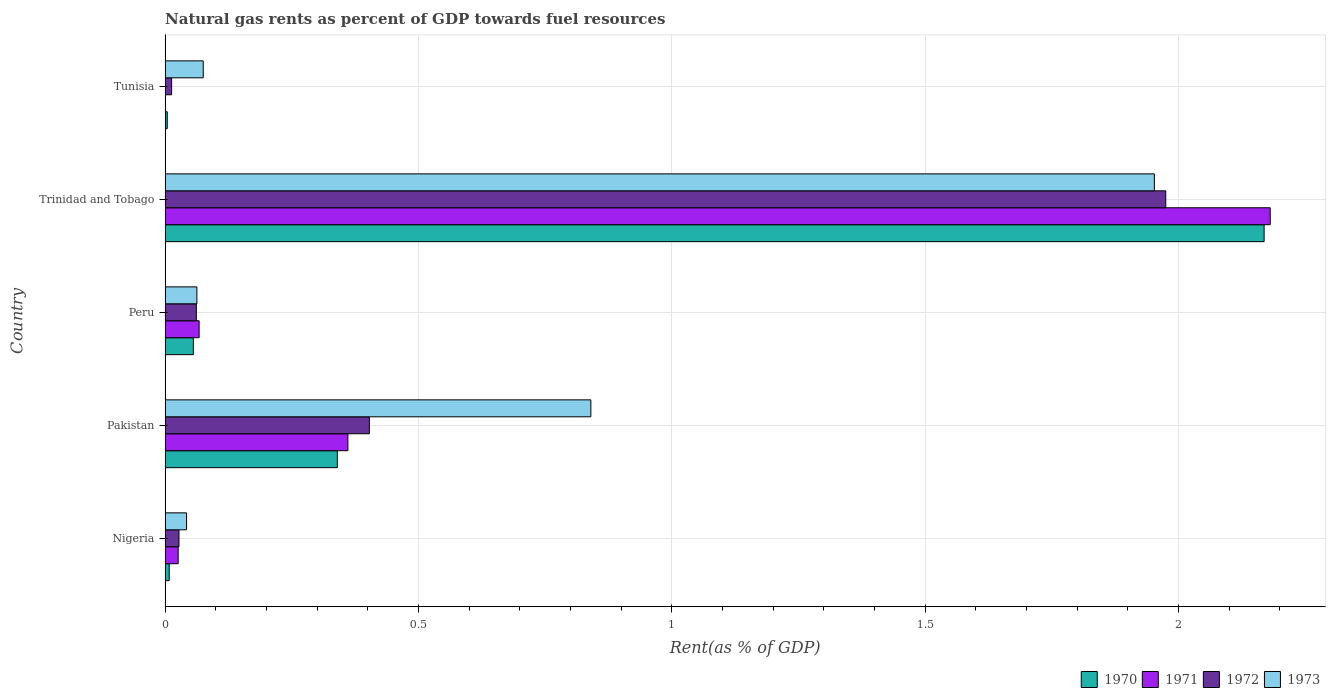How many groups of bars are there?
Your answer should be compact. 5. Are the number of bars per tick equal to the number of legend labels?
Offer a very short reply. Yes. What is the label of the 3rd group of bars from the top?
Offer a very short reply. Peru. What is the matural gas rent in 1972 in Pakistan?
Your response must be concise. 0.4. Across all countries, what is the maximum matural gas rent in 1972?
Offer a very short reply. 1.98. Across all countries, what is the minimum matural gas rent in 1970?
Give a very brief answer. 0. In which country was the matural gas rent in 1972 maximum?
Provide a succinct answer. Trinidad and Tobago. In which country was the matural gas rent in 1972 minimum?
Your answer should be compact. Tunisia. What is the total matural gas rent in 1973 in the graph?
Keep it short and to the point. 2.97. What is the difference between the matural gas rent in 1972 in Peru and that in Trinidad and Tobago?
Offer a very short reply. -1.91. What is the difference between the matural gas rent in 1971 in Tunisia and the matural gas rent in 1973 in Pakistan?
Keep it short and to the point. -0.84. What is the average matural gas rent in 1971 per country?
Ensure brevity in your answer.  0.53. What is the difference between the matural gas rent in 1972 and matural gas rent in 1970 in Peru?
Make the answer very short. 0.01. In how many countries, is the matural gas rent in 1973 greater than 0.1 %?
Your response must be concise. 2. What is the ratio of the matural gas rent in 1971 in Nigeria to that in Tunisia?
Your response must be concise. 34.77. Is the matural gas rent in 1972 in Pakistan less than that in Peru?
Provide a short and direct response. No. What is the difference between the highest and the second highest matural gas rent in 1972?
Provide a succinct answer. 1.57. What is the difference between the highest and the lowest matural gas rent in 1972?
Provide a short and direct response. 1.96. Is the sum of the matural gas rent in 1972 in Nigeria and Tunisia greater than the maximum matural gas rent in 1973 across all countries?
Ensure brevity in your answer.  No. What does the 3rd bar from the top in Tunisia represents?
Provide a succinct answer. 1971. Is it the case that in every country, the sum of the matural gas rent in 1973 and matural gas rent in 1971 is greater than the matural gas rent in 1970?
Give a very brief answer. Yes. Are all the bars in the graph horizontal?
Your response must be concise. Yes. How many countries are there in the graph?
Provide a short and direct response. 5. What is the difference between two consecutive major ticks on the X-axis?
Give a very brief answer. 0.5. Are the values on the major ticks of X-axis written in scientific E-notation?
Provide a succinct answer. No. Does the graph contain grids?
Keep it short and to the point. Yes. How many legend labels are there?
Ensure brevity in your answer.  4. How are the legend labels stacked?
Your response must be concise. Horizontal. What is the title of the graph?
Your answer should be compact. Natural gas rents as percent of GDP towards fuel resources. Does "1988" appear as one of the legend labels in the graph?
Keep it short and to the point. No. What is the label or title of the X-axis?
Your answer should be compact. Rent(as % of GDP). What is the label or title of the Y-axis?
Your response must be concise. Country. What is the Rent(as % of GDP) of 1970 in Nigeria?
Provide a short and direct response. 0.01. What is the Rent(as % of GDP) of 1971 in Nigeria?
Make the answer very short. 0.03. What is the Rent(as % of GDP) in 1972 in Nigeria?
Offer a very short reply. 0.03. What is the Rent(as % of GDP) of 1973 in Nigeria?
Provide a succinct answer. 0.04. What is the Rent(as % of GDP) of 1970 in Pakistan?
Give a very brief answer. 0.34. What is the Rent(as % of GDP) in 1971 in Pakistan?
Give a very brief answer. 0.36. What is the Rent(as % of GDP) in 1972 in Pakistan?
Offer a terse response. 0.4. What is the Rent(as % of GDP) in 1973 in Pakistan?
Keep it short and to the point. 0.84. What is the Rent(as % of GDP) in 1970 in Peru?
Ensure brevity in your answer.  0.06. What is the Rent(as % of GDP) of 1971 in Peru?
Provide a succinct answer. 0.07. What is the Rent(as % of GDP) of 1972 in Peru?
Your answer should be very brief. 0.06. What is the Rent(as % of GDP) of 1973 in Peru?
Offer a very short reply. 0.06. What is the Rent(as % of GDP) of 1970 in Trinidad and Tobago?
Keep it short and to the point. 2.17. What is the Rent(as % of GDP) of 1971 in Trinidad and Tobago?
Provide a succinct answer. 2.18. What is the Rent(as % of GDP) of 1972 in Trinidad and Tobago?
Offer a terse response. 1.98. What is the Rent(as % of GDP) in 1973 in Trinidad and Tobago?
Ensure brevity in your answer.  1.95. What is the Rent(as % of GDP) in 1970 in Tunisia?
Give a very brief answer. 0. What is the Rent(as % of GDP) of 1971 in Tunisia?
Give a very brief answer. 0. What is the Rent(as % of GDP) in 1972 in Tunisia?
Give a very brief answer. 0.01. What is the Rent(as % of GDP) of 1973 in Tunisia?
Offer a very short reply. 0.08. Across all countries, what is the maximum Rent(as % of GDP) of 1970?
Provide a short and direct response. 2.17. Across all countries, what is the maximum Rent(as % of GDP) of 1971?
Offer a very short reply. 2.18. Across all countries, what is the maximum Rent(as % of GDP) of 1972?
Your answer should be very brief. 1.98. Across all countries, what is the maximum Rent(as % of GDP) of 1973?
Provide a succinct answer. 1.95. Across all countries, what is the minimum Rent(as % of GDP) in 1970?
Give a very brief answer. 0. Across all countries, what is the minimum Rent(as % of GDP) in 1971?
Your answer should be very brief. 0. Across all countries, what is the minimum Rent(as % of GDP) in 1972?
Provide a short and direct response. 0.01. Across all countries, what is the minimum Rent(as % of GDP) of 1973?
Offer a very short reply. 0.04. What is the total Rent(as % of GDP) of 1970 in the graph?
Offer a terse response. 2.58. What is the total Rent(as % of GDP) of 1971 in the graph?
Your response must be concise. 2.64. What is the total Rent(as % of GDP) in 1972 in the graph?
Keep it short and to the point. 2.48. What is the total Rent(as % of GDP) in 1973 in the graph?
Keep it short and to the point. 2.97. What is the difference between the Rent(as % of GDP) in 1970 in Nigeria and that in Pakistan?
Provide a short and direct response. -0.33. What is the difference between the Rent(as % of GDP) of 1971 in Nigeria and that in Pakistan?
Your answer should be very brief. -0.34. What is the difference between the Rent(as % of GDP) in 1972 in Nigeria and that in Pakistan?
Give a very brief answer. -0.38. What is the difference between the Rent(as % of GDP) in 1973 in Nigeria and that in Pakistan?
Keep it short and to the point. -0.8. What is the difference between the Rent(as % of GDP) in 1970 in Nigeria and that in Peru?
Give a very brief answer. -0.05. What is the difference between the Rent(as % of GDP) of 1971 in Nigeria and that in Peru?
Give a very brief answer. -0.04. What is the difference between the Rent(as % of GDP) in 1972 in Nigeria and that in Peru?
Provide a short and direct response. -0.03. What is the difference between the Rent(as % of GDP) of 1973 in Nigeria and that in Peru?
Offer a very short reply. -0.02. What is the difference between the Rent(as % of GDP) of 1970 in Nigeria and that in Trinidad and Tobago?
Offer a very short reply. -2.16. What is the difference between the Rent(as % of GDP) in 1971 in Nigeria and that in Trinidad and Tobago?
Ensure brevity in your answer.  -2.16. What is the difference between the Rent(as % of GDP) of 1972 in Nigeria and that in Trinidad and Tobago?
Provide a succinct answer. -1.95. What is the difference between the Rent(as % of GDP) of 1973 in Nigeria and that in Trinidad and Tobago?
Your response must be concise. -1.91. What is the difference between the Rent(as % of GDP) in 1970 in Nigeria and that in Tunisia?
Offer a terse response. 0. What is the difference between the Rent(as % of GDP) of 1971 in Nigeria and that in Tunisia?
Make the answer very short. 0.03. What is the difference between the Rent(as % of GDP) of 1972 in Nigeria and that in Tunisia?
Make the answer very short. 0.01. What is the difference between the Rent(as % of GDP) of 1973 in Nigeria and that in Tunisia?
Give a very brief answer. -0.03. What is the difference between the Rent(as % of GDP) in 1970 in Pakistan and that in Peru?
Make the answer very short. 0.28. What is the difference between the Rent(as % of GDP) of 1971 in Pakistan and that in Peru?
Ensure brevity in your answer.  0.29. What is the difference between the Rent(as % of GDP) of 1972 in Pakistan and that in Peru?
Ensure brevity in your answer.  0.34. What is the difference between the Rent(as % of GDP) of 1973 in Pakistan and that in Peru?
Keep it short and to the point. 0.78. What is the difference between the Rent(as % of GDP) in 1970 in Pakistan and that in Trinidad and Tobago?
Ensure brevity in your answer.  -1.83. What is the difference between the Rent(as % of GDP) in 1971 in Pakistan and that in Trinidad and Tobago?
Offer a terse response. -1.82. What is the difference between the Rent(as % of GDP) in 1972 in Pakistan and that in Trinidad and Tobago?
Your answer should be very brief. -1.57. What is the difference between the Rent(as % of GDP) in 1973 in Pakistan and that in Trinidad and Tobago?
Make the answer very short. -1.11. What is the difference between the Rent(as % of GDP) in 1970 in Pakistan and that in Tunisia?
Offer a terse response. 0.34. What is the difference between the Rent(as % of GDP) of 1971 in Pakistan and that in Tunisia?
Provide a short and direct response. 0.36. What is the difference between the Rent(as % of GDP) of 1972 in Pakistan and that in Tunisia?
Give a very brief answer. 0.39. What is the difference between the Rent(as % of GDP) of 1973 in Pakistan and that in Tunisia?
Offer a very short reply. 0.77. What is the difference between the Rent(as % of GDP) in 1970 in Peru and that in Trinidad and Tobago?
Ensure brevity in your answer.  -2.11. What is the difference between the Rent(as % of GDP) in 1971 in Peru and that in Trinidad and Tobago?
Provide a succinct answer. -2.11. What is the difference between the Rent(as % of GDP) in 1972 in Peru and that in Trinidad and Tobago?
Make the answer very short. -1.91. What is the difference between the Rent(as % of GDP) of 1973 in Peru and that in Trinidad and Tobago?
Make the answer very short. -1.89. What is the difference between the Rent(as % of GDP) of 1970 in Peru and that in Tunisia?
Your answer should be compact. 0.05. What is the difference between the Rent(as % of GDP) of 1971 in Peru and that in Tunisia?
Make the answer very short. 0.07. What is the difference between the Rent(as % of GDP) of 1972 in Peru and that in Tunisia?
Provide a short and direct response. 0.05. What is the difference between the Rent(as % of GDP) of 1973 in Peru and that in Tunisia?
Make the answer very short. -0.01. What is the difference between the Rent(as % of GDP) in 1970 in Trinidad and Tobago and that in Tunisia?
Make the answer very short. 2.17. What is the difference between the Rent(as % of GDP) of 1971 in Trinidad and Tobago and that in Tunisia?
Offer a very short reply. 2.18. What is the difference between the Rent(as % of GDP) of 1972 in Trinidad and Tobago and that in Tunisia?
Your answer should be compact. 1.96. What is the difference between the Rent(as % of GDP) in 1973 in Trinidad and Tobago and that in Tunisia?
Your answer should be very brief. 1.88. What is the difference between the Rent(as % of GDP) in 1970 in Nigeria and the Rent(as % of GDP) in 1971 in Pakistan?
Offer a very short reply. -0.35. What is the difference between the Rent(as % of GDP) of 1970 in Nigeria and the Rent(as % of GDP) of 1972 in Pakistan?
Make the answer very short. -0.4. What is the difference between the Rent(as % of GDP) in 1970 in Nigeria and the Rent(as % of GDP) in 1973 in Pakistan?
Your response must be concise. -0.83. What is the difference between the Rent(as % of GDP) in 1971 in Nigeria and the Rent(as % of GDP) in 1972 in Pakistan?
Your answer should be compact. -0.38. What is the difference between the Rent(as % of GDP) of 1971 in Nigeria and the Rent(as % of GDP) of 1973 in Pakistan?
Your answer should be compact. -0.81. What is the difference between the Rent(as % of GDP) of 1972 in Nigeria and the Rent(as % of GDP) of 1973 in Pakistan?
Offer a terse response. -0.81. What is the difference between the Rent(as % of GDP) in 1970 in Nigeria and the Rent(as % of GDP) in 1971 in Peru?
Your answer should be compact. -0.06. What is the difference between the Rent(as % of GDP) of 1970 in Nigeria and the Rent(as % of GDP) of 1972 in Peru?
Your answer should be very brief. -0.05. What is the difference between the Rent(as % of GDP) of 1970 in Nigeria and the Rent(as % of GDP) of 1973 in Peru?
Provide a short and direct response. -0.05. What is the difference between the Rent(as % of GDP) in 1971 in Nigeria and the Rent(as % of GDP) in 1972 in Peru?
Keep it short and to the point. -0.04. What is the difference between the Rent(as % of GDP) of 1971 in Nigeria and the Rent(as % of GDP) of 1973 in Peru?
Offer a very short reply. -0.04. What is the difference between the Rent(as % of GDP) of 1972 in Nigeria and the Rent(as % of GDP) of 1973 in Peru?
Ensure brevity in your answer.  -0.04. What is the difference between the Rent(as % of GDP) of 1970 in Nigeria and the Rent(as % of GDP) of 1971 in Trinidad and Tobago?
Offer a terse response. -2.17. What is the difference between the Rent(as % of GDP) in 1970 in Nigeria and the Rent(as % of GDP) in 1972 in Trinidad and Tobago?
Ensure brevity in your answer.  -1.97. What is the difference between the Rent(as % of GDP) of 1970 in Nigeria and the Rent(as % of GDP) of 1973 in Trinidad and Tobago?
Provide a short and direct response. -1.94. What is the difference between the Rent(as % of GDP) in 1971 in Nigeria and the Rent(as % of GDP) in 1972 in Trinidad and Tobago?
Your answer should be compact. -1.95. What is the difference between the Rent(as % of GDP) in 1971 in Nigeria and the Rent(as % of GDP) in 1973 in Trinidad and Tobago?
Provide a short and direct response. -1.93. What is the difference between the Rent(as % of GDP) in 1972 in Nigeria and the Rent(as % of GDP) in 1973 in Trinidad and Tobago?
Offer a very short reply. -1.93. What is the difference between the Rent(as % of GDP) in 1970 in Nigeria and the Rent(as % of GDP) in 1971 in Tunisia?
Your response must be concise. 0.01. What is the difference between the Rent(as % of GDP) of 1970 in Nigeria and the Rent(as % of GDP) of 1972 in Tunisia?
Give a very brief answer. -0. What is the difference between the Rent(as % of GDP) of 1970 in Nigeria and the Rent(as % of GDP) of 1973 in Tunisia?
Make the answer very short. -0.07. What is the difference between the Rent(as % of GDP) in 1971 in Nigeria and the Rent(as % of GDP) in 1972 in Tunisia?
Keep it short and to the point. 0.01. What is the difference between the Rent(as % of GDP) in 1971 in Nigeria and the Rent(as % of GDP) in 1973 in Tunisia?
Your answer should be very brief. -0.05. What is the difference between the Rent(as % of GDP) of 1972 in Nigeria and the Rent(as % of GDP) of 1973 in Tunisia?
Provide a succinct answer. -0.05. What is the difference between the Rent(as % of GDP) of 1970 in Pakistan and the Rent(as % of GDP) of 1971 in Peru?
Ensure brevity in your answer.  0.27. What is the difference between the Rent(as % of GDP) of 1970 in Pakistan and the Rent(as % of GDP) of 1972 in Peru?
Give a very brief answer. 0.28. What is the difference between the Rent(as % of GDP) of 1970 in Pakistan and the Rent(as % of GDP) of 1973 in Peru?
Ensure brevity in your answer.  0.28. What is the difference between the Rent(as % of GDP) of 1971 in Pakistan and the Rent(as % of GDP) of 1972 in Peru?
Offer a terse response. 0.3. What is the difference between the Rent(as % of GDP) of 1971 in Pakistan and the Rent(as % of GDP) of 1973 in Peru?
Your response must be concise. 0.3. What is the difference between the Rent(as % of GDP) of 1972 in Pakistan and the Rent(as % of GDP) of 1973 in Peru?
Offer a very short reply. 0.34. What is the difference between the Rent(as % of GDP) in 1970 in Pakistan and the Rent(as % of GDP) in 1971 in Trinidad and Tobago?
Give a very brief answer. -1.84. What is the difference between the Rent(as % of GDP) in 1970 in Pakistan and the Rent(as % of GDP) in 1972 in Trinidad and Tobago?
Make the answer very short. -1.64. What is the difference between the Rent(as % of GDP) in 1970 in Pakistan and the Rent(as % of GDP) in 1973 in Trinidad and Tobago?
Provide a succinct answer. -1.61. What is the difference between the Rent(as % of GDP) of 1971 in Pakistan and the Rent(as % of GDP) of 1972 in Trinidad and Tobago?
Keep it short and to the point. -1.61. What is the difference between the Rent(as % of GDP) in 1971 in Pakistan and the Rent(as % of GDP) in 1973 in Trinidad and Tobago?
Your answer should be compact. -1.59. What is the difference between the Rent(as % of GDP) in 1972 in Pakistan and the Rent(as % of GDP) in 1973 in Trinidad and Tobago?
Ensure brevity in your answer.  -1.55. What is the difference between the Rent(as % of GDP) of 1970 in Pakistan and the Rent(as % of GDP) of 1971 in Tunisia?
Offer a very short reply. 0.34. What is the difference between the Rent(as % of GDP) of 1970 in Pakistan and the Rent(as % of GDP) of 1972 in Tunisia?
Offer a very short reply. 0.33. What is the difference between the Rent(as % of GDP) in 1970 in Pakistan and the Rent(as % of GDP) in 1973 in Tunisia?
Offer a very short reply. 0.26. What is the difference between the Rent(as % of GDP) of 1971 in Pakistan and the Rent(as % of GDP) of 1972 in Tunisia?
Ensure brevity in your answer.  0.35. What is the difference between the Rent(as % of GDP) of 1971 in Pakistan and the Rent(as % of GDP) of 1973 in Tunisia?
Your response must be concise. 0.29. What is the difference between the Rent(as % of GDP) in 1972 in Pakistan and the Rent(as % of GDP) in 1973 in Tunisia?
Your response must be concise. 0.33. What is the difference between the Rent(as % of GDP) in 1970 in Peru and the Rent(as % of GDP) in 1971 in Trinidad and Tobago?
Give a very brief answer. -2.13. What is the difference between the Rent(as % of GDP) of 1970 in Peru and the Rent(as % of GDP) of 1972 in Trinidad and Tobago?
Make the answer very short. -1.92. What is the difference between the Rent(as % of GDP) of 1970 in Peru and the Rent(as % of GDP) of 1973 in Trinidad and Tobago?
Make the answer very short. -1.9. What is the difference between the Rent(as % of GDP) in 1971 in Peru and the Rent(as % of GDP) in 1972 in Trinidad and Tobago?
Ensure brevity in your answer.  -1.91. What is the difference between the Rent(as % of GDP) of 1971 in Peru and the Rent(as % of GDP) of 1973 in Trinidad and Tobago?
Offer a terse response. -1.89. What is the difference between the Rent(as % of GDP) in 1972 in Peru and the Rent(as % of GDP) in 1973 in Trinidad and Tobago?
Your answer should be very brief. -1.89. What is the difference between the Rent(as % of GDP) of 1970 in Peru and the Rent(as % of GDP) of 1971 in Tunisia?
Make the answer very short. 0.06. What is the difference between the Rent(as % of GDP) of 1970 in Peru and the Rent(as % of GDP) of 1972 in Tunisia?
Provide a succinct answer. 0.04. What is the difference between the Rent(as % of GDP) in 1970 in Peru and the Rent(as % of GDP) in 1973 in Tunisia?
Provide a succinct answer. -0.02. What is the difference between the Rent(as % of GDP) of 1971 in Peru and the Rent(as % of GDP) of 1972 in Tunisia?
Offer a very short reply. 0.05. What is the difference between the Rent(as % of GDP) in 1971 in Peru and the Rent(as % of GDP) in 1973 in Tunisia?
Your answer should be compact. -0.01. What is the difference between the Rent(as % of GDP) of 1972 in Peru and the Rent(as % of GDP) of 1973 in Tunisia?
Offer a terse response. -0.01. What is the difference between the Rent(as % of GDP) in 1970 in Trinidad and Tobago and the Rent(as % of GDP) in 1971 in Tunisia?
Make the answer very short. 2.17. What is the difference between the Rent(as % of GDP) in 1970 in Trinidad and Tobago and the Rent(as % of GDP) in 1972 in Tunisia?
Make the answer very short. 2.16. What is the difference between the Rent(as % of GDP) of 1970 in Trinidad and Tobago and the Rent(as % of GDP) of 1973 in Tunisia?
Offer a terse response. 2.09. What is the difference between the Rent(as % of GDP) in 1971 in Trinidad and Tobago and the Rent(as % of GDP) in 1972 in Tunisia?
Offer a terse response. 2.17. What is the difference between the Rent(as % of GDP) of 1971 in Trinidad and Tobago and the Rent(as % of GDP) of 1973 in Tunisia?
Provide a succinct answer. 2.11. What is the difference between the Rent(as % of GDP) of 1972 in Trinidad and Tobago and the Rent(as % of GDP) of 1973 in Tunisia?
Ensure brevity in your answer.  1.9. What is the average Rent(as % of GDP) of 1970 per country?
Make the answer very short. 0.52. What is the average Rent(as % of GDP) in 1971 per country?
Offer a very short reply. 0.53. What is the average Rent(as % of GDP) in 1972 per country?
Offer a terse response. 0.5. What is the average Rent(as % of GDP) in 1973 per country?
Your response must be concise. 0.59. What is the difference between the Rent(as % of GDP) of 1970 and Rent(as % of GDP) of 1971 in Nigeria?
Offer a very short reply. -0.02. What is the difference between the Rent(as % of GDP) in 1970 and Rent(as % of GDP) in 1972 in Nigeria?
Make the answer very short. -0.02. What is the difference between the Rent(as % of GDP) in 1970 and Rent(as % of GDP) in 1973 in Nigeria?
Ensure brevity in your answer.  -0.03. What is the difference between the Rent(as % of GDP) of 1971 and Rent(as % of GDP) of 1972 in Nigeria?
Your response must be concise. -0. What is the difference between the Rent(as % of GDP) in 1971 and Rent(as % of GDP) in 1973 in Nigeria?
Your answer should be very brief. -0.02. What is the difference between the Rent(as % of GDP) of 1972 and Rent(as % of GDP) of 1973 in Nigeria?
Make the answer very short. -0.01. What is the difference between the Rent(as % of GDP) of 1970 and Rent(as % of GDP) of 1971 in Pakistan?
Your answer should be compact. -0.02. What is the difference between the Rent(as % of GDP) in 1970 and Rent(as % of GDP) in 1972 in Pakistan?
Your answer should be very brief. -0.06. What is the difference between the Rent(as % of GDP) of 1970 and Rent(as % of GDP) of 1973 in Pakistan?
Your answer should be compact. -0.5. What is the difference between the Rent(as % of GDP) in 1971 and Rent(as % of GDP) in 1972 in Pakistan?
Offer a very short reply. -0.04. What is the difference between the Rent(as % of GDP) of 1971 and Rent(as % of GDP) of 1973 in Pakistan?
Ensure brevity in your answer.  -0.48. What is the difference between the Rent(as % of GDP) of 1972 and Rent(as % of GDP) of 1973 in Pakistan?
Ensure brevity in your answer.  -0.44. What is the difference between the Rent(as % of GDP) of 1970 and Rent(as % of GDP) of 1971 in Peru?
Provide a short and direct response. -0.01. What is the difference between the Rent(as % of GDP) in 1970 and Rent(as % of GDP) in 1972 in Peru?
Your answer should be very brief. -0.01. What is the difference between the Rent(as % of GDP) in 1970 and Rent(as % of GDP) in 1973 in Peru?
Ensure brevity in your answer.  -0.01. What is the difference between the Rent(as % of GDP) in 1971 and Rent(as % of GDP) in 1972 in Peru?
Provide a short and direct response. 0.01. What is the difference between the Rent(as % of GDP) of 1971 and Rent(as % of GDP) of 1973 in Peru?
Your answer should be very brief. 0. What is the difference between the Rent(as % of GDP) in 1972 and Rent(as % of GDP) in 1973 in Peru?
Your answer should be compact. -0. What is the difference between the Rent(as % of GDP) of 1970 and Rent(as % of GDP) of 1971 in Trinidad and Tobago?
Your answer should be compact. -0.01. What is the difference between the Rent(as % of GDP) of 1970 and Rent(as % of GDP) of 1972 in Trinidad and Tobago?
Ensure brevity in your answer.  0.19. What is the difference between the Rent(as % of GDP) of 1970 and Rent(as % of GDP) of 1973 in Trinidad and Tobago?
Keep it short and to the point. 0.22. What is the difference between the Rent(as % of GDP) in 1971 and Rent(as % of GDP) in 1972 in Trinidad and Tobago?
Provide a short and direct response. 0.21. What is the difference between the Rent(as % of GDP) in 1971 and Rent(as % of GDP) in 1973 in Trinidad and Tobago?
Provide a short and direct response. 0.23. What is the difference between the Rent(as % of GDP) in 1972 and Rent(as % of GDP) in 1973 in Trinidad and Tobago?
Provide a succinct answer. 0.02. What is the difference between the Rent(as % of GDP) in 1970 and Rent(as % of GDP) in 1971 in Tunisia?
Your answer should be very brief. 0. What is the difference between the Rent(as % of GDP) in 1970 and Rent(as % of GDP) in 1972 in Tunisia?
Your answer should be very brief. -0.01. What is the difference between the Rent(as % of GDP) of 1970 and Rent(as % of GDP) of 1973 in Tunisia?
Your answer should be very brief. -0.07. What is the difference between the Rent(as % of GDP) of 1971 and Rent(as % of GDP) of 1972 in Tunisia?
Your answer should be very brief. -0.01. What is the difference between the Rent(as % of GDP) of 1971 and Rent(as % of GDP) of 1973 in Tunisia?
Offer a very short reply. -0.07. What is the difference between the Rent(as % of GDP) in 1972 and Rent(as % of GDP) in 1973 in Tunisia?
Offer a very short reply. -0.06. What is the ratio of the Rent(as % of GDP) in 1970 in Nigeria to that in Pakistan?
Your answer should be compact. 0.02. What is the ratio of the Rent(as % of GDP) of 1971 in Nigeria to that in Pakistan?
Make the answer very short. 0.07. What is the ratio of the Rent(as % of GDP) in 1972 in Nigeria to that in Pakistan?
Provide a succinct answer. 0.07. What is the ratio of the Rent(as % of GDP) in 1973 in Nigeria to that in Pakistan?
Give a very brief answer. 0.05. What is the ratio of the Rent(as % of GDP) in 1970 in Nigeria to that in Peru?
Your response must be concise. 0.15. What is the ratio of the Rent(as % of GDP) of 1971 in Nigeria to that in Peru?
Your answer should be very brief. 0.38. What is the ratio of the Rent(as % of GDP) of 1972 in Nigeria to that in Peru?
Provide a short and direct response. 0.44. What is the ratio of the Rent(as % of GDP) of 1973 in Nigeria to that in Peru?
Your answer should be very brief. 0.67. What is the ratio of the Rent(as % of GDP) of 1970 in Nigeria to that in Trinidad and Tobago?
Ensure brevity in your answer.  0. What is the ratio of the Rent(as % of GDP) of 1971 in Nigeria to that in Trinidad and Tobago?
Give a very brief answer. 0.01. What is the ratio of the Rent(as % of GDP) of 1972 in Nigeria to that in Trinidad and Tobago?
Offer a terse response. 0.01. What is the ratio of the Rent(as % of GDP) of 1973 in Nigeria to that in Trinidad and Tobago?
Your answer should be very brief. 0.02. What is the ratio of the Rent(as % of GDP) in 1970 in Nigeria to that in Tunisia?
Your response must be concise. 1.92. What is the ratio of the Rent(as % of GDP) of 1971 in Nigeria to that in Tunisia?
Provide a short and direct response. 34.77. What is the ratio of the Rent(as % of GDP) of 1972 in Nigeria to that in Tunisia?
Keep it short and to the point. 2.13. What is the ratio of the Rent(as % of GDP) in 1973 in Nigeria to that in Tunisia?
Keep it short and to the point. 0.56. What is the ratio of the Rent(as % of GDP) of 1970 in Pakistan to that in Peru?
Ensure brevity in your answer.  6.1. What is the ratio of the Rent(as % of GDP) in 1971 in Pakistan to that in Peru?
Make the answer very short. 5.37. What is the ratio of the Rent(as % of GDP) of 1972 in Pakistan to that in Peru?
Keep it short and to the point. 6.54. What is the ratio of the Rent(as % of GDP) of 1973 in Pakistan to that in Peru?
Your response must be concise. 13.39. What is the ratio of the Rent(as % of GDP) of 1970 in Pakistan to that in Trinidad and Tobago?
Your response must be concise. 0.16. What is the ratio of the Rent(as % of GDP) of 1971 in Pakistan to that in Trinidad and Tobago?
Keep it short and to the point. 0.17. What is the ratio of the Rent(as % of GDP) in 1972 in Pakistan to that in Trinidad and Tobago?
Your answer should be compact. 0.2. What is the ratio of the Rent(as % of GDP) in 1973 in Pakistan to that in Trinidad and Tobago?
Keep it short and to the point. 0.43. What is the ratio of the Rent(as % of GDP) of 1970 in Pakistan to that in Tunisia?
Offer a terse response. 80.16. What is the ratio of the Rent(as % of GDP) in 1971 in Pakistan to that in Tunisia?
Ensure brevity in your answer.  486.4. What is the ratio of the Rent(as % of GDP) of 1972 in Pakistan to that in Tunisia?
Your answer should be very brief. 31.31. What is the ratio of the Rent(as % of GDP) in 1973 in Pakistan to that in Tunisia?
Your answer should be compact. 11.17. What is the ratio of the Rent(as % of GDP) of 1970 in Peru to that in Trinidad and Tobago?
Your answer should be very brief. 0.03. What is the ratio of the Rent(as % of GDP) in 1971 in Peru to that in Trinidad and Tobago?
Keep it short and to the point. 0.03. What is the ratio of the Rent(as % of GDP) in 1972 in Peru to that in Trinidad and Tobago?
Your response must be concise. 0.03. What is the ratio of the Rent(as % of GDP) in 1973 in Peru to that in Trinidad and Tobago?
Your answer should be compact. 0.03. What is the ratio of the Rent(as % of GDP) in 1970 in Peru to that in Tunisia?
Your answer should be very brief. 13.15. What is the ratio of the Rent(as % of GDP) in 1971 in Peru to that in Tunisia?
Provide a short and direct response. 90.55. What is the ratio of the Rent(as % of GDP) of 1972 in Peru to that in Tunisia?
Provide a succinct answer. 4.79. What is the ratio of the Rent(as % of GDP) in 1973 in Peru to that in Tunisia?
Your answer should be compact. 0.83. What is the ratio of the Rent(as % of GDP) of 1970 in Trinidad and Tobago to that in Tunisia?
Make the answer very short. 511.49. What is the ratio of the Rent(as % of GDP) of 1971 in Trinidad and Tobago to that in Tunisia?
Offer a terse response. 2940.6. What is the ratio of the Rent(as % of GDP) in 1972 in Trinidad and Tobago to that in Tunisia?
Provide a succinct answer. 153.39. What is the ratio of the Rent(as % of GDP) in 1973 in Trinidad and Tobago to that in Tunisia?
Provide a succinct answer. 25.94. What is the difference between the highest and the second highest Rent(as % of GDP) in 1970?
Your answer should be compact. 1.83. What is the difference between the highest and the second highest Rent(as % of GDP) of 1971?
Your response must be concise. 1.82. What is the difference between the highest and the second highest Rent(as % of GDP) in 1972?
Give a very brief answer. 1.57. What is the difference between the highest and the second highest Rent(as % of GDP) of 1973?
Your answer should be very brief. 1.11. What is the difference between the highest and the lowest Rent(as % of GDP) of 1970?
Provide a succinct answer. 2.17. What is the difference between the highest and the lowest Rent(as % of GDP) of 1971?
Make the answer very short. 2.18. What is the difference between the highest and the lowest Rent(as % of GDP) in 1972?
Your answer should be very brief. 1.96. What is the difference between the highest and the lowest Rent(as % of GDP) of 1973?
Your answer should be very brief. 1.91. 